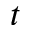<formula> <loc_0><loc_0><loc_500><loc_500>t</formula> 